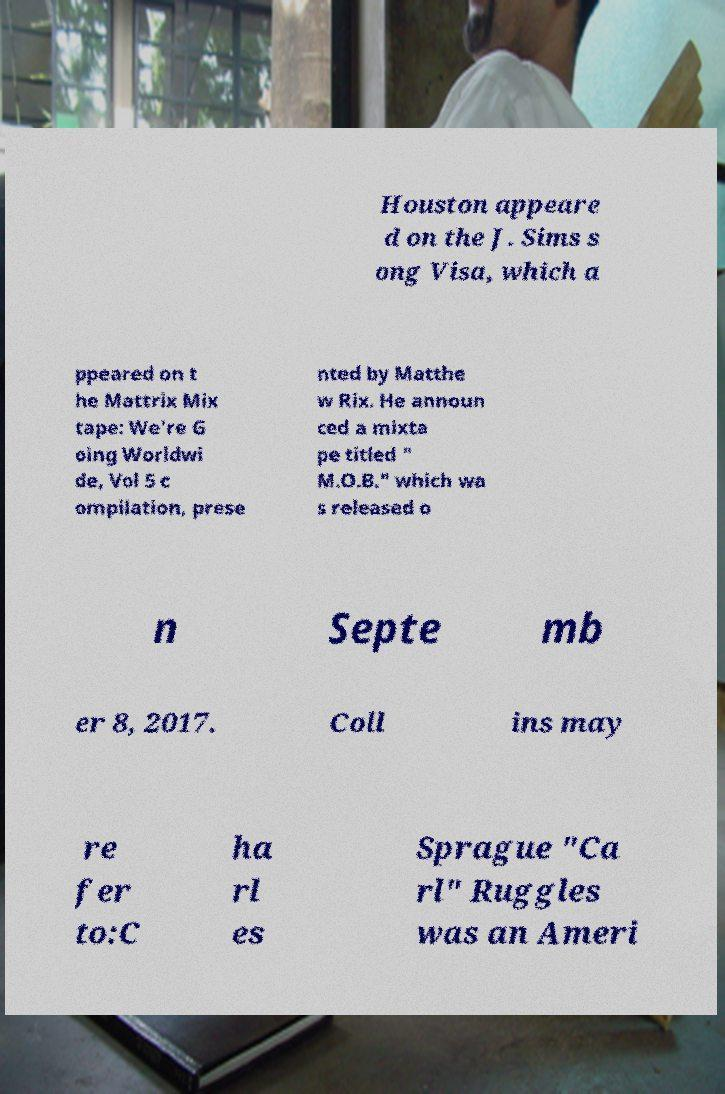Can you read and provide the text displayed in the image?This photo seems to have some interesting text. Can you extract and type it out for me? Houston appeare d on the J. Sims s ong Visa, which a ppeared on t he Mattrix Mix tape: We're G oing Worldwi de, Vol 5 c ompilation, prese nted by Matthe w Rix. He announ ced a mixta pe titled " M.O.B." which wa s released o n Septe mb er 8, 2017. Coll ins may re fer to:C ha rl es Sprague "Ca rl" Ruggles was an Ameri 